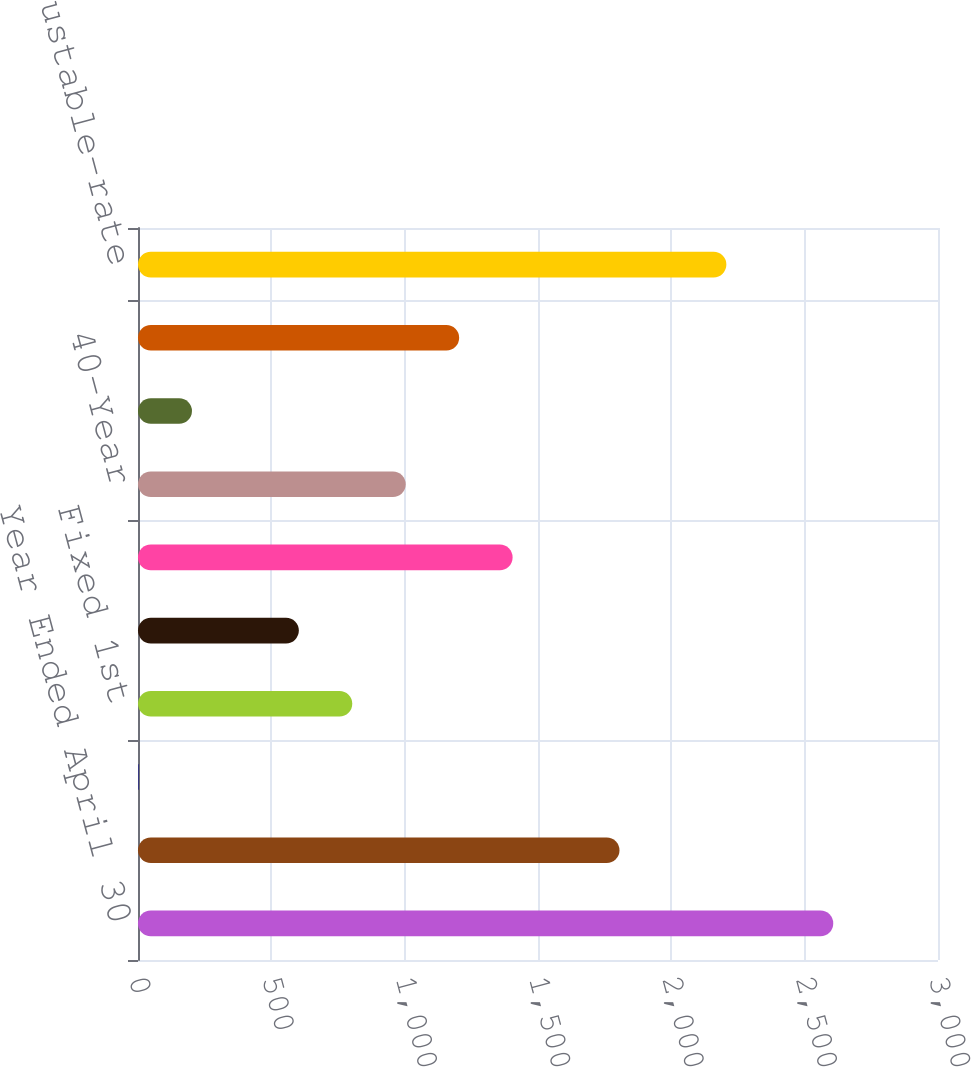Convert chart. <chart><loc_0><loc_0><loc_500><loc_500><bar_chart><fcel>Year Ended April 30<fcel>2-year ARM<fcel>3-year ARM<fcel>Fixed 1st<fcel>Fixed 2nd<fcel>Interest only 1st<fcel>40-Year<fcel>Other<fcel>Percentage of fixed-rate<fcel>Percentage of adjustable-rate<nl><fcel>2607.23<fcel>1805.59<fcel>1.9<fcel>803.54<fcel>603.13<fcel>1404.77<fcel>1003.95<fcel>202.31<fcel>1204.36<fcel>2206.41<nl></chart> 